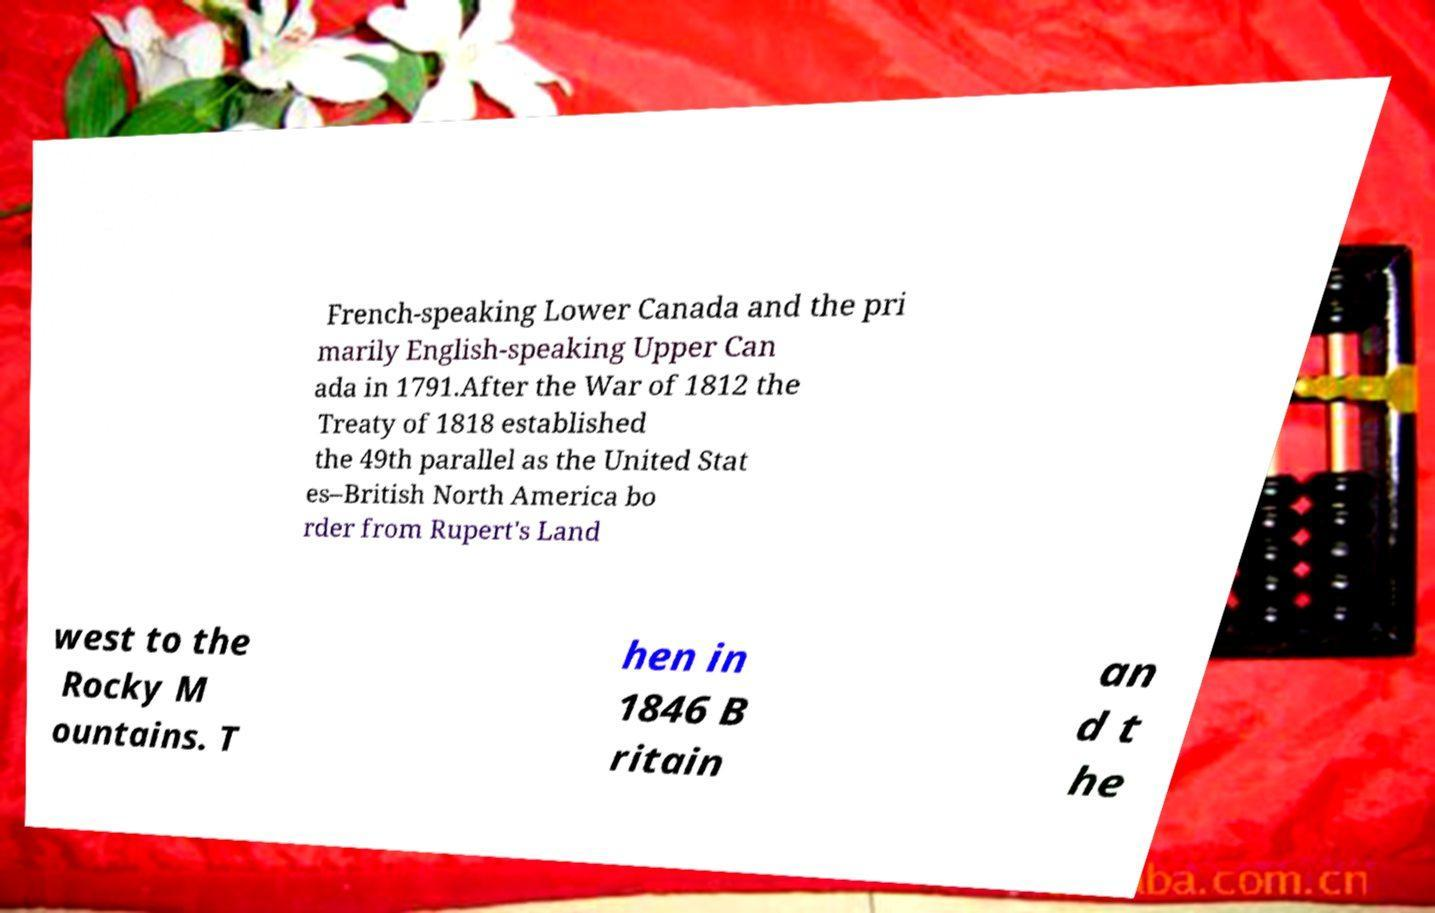Can you accurately transcribe the text from the provided image for me? French-speaking Lower Canada and the pri marily English-speaking Upper Can ada in 1791.After the War of 1812 the Treaty of 1818 established the 49th parallel as the United Stat es–British North America bo rder from Rupert's Land west to the Rocky M ountains. T hen in 1846 B ritain an d t he 